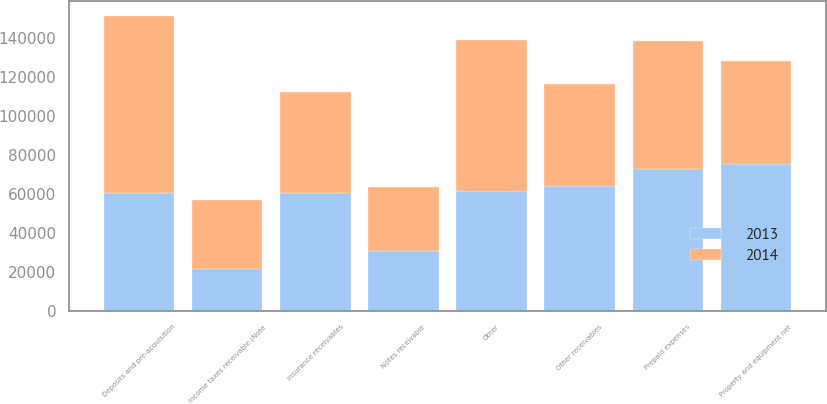Convert chart. <chart><loc_0><loc_0><loc_500><loc_500><stacked_bar_chart><ecel><fcel>Insurance receivables<fcel>Notes receivable<fcel>Other receivables<fcel>Prepaid expenses<fcel>Deposits and pre-acquisition<fcel>Property and equipment net<fcel>Income taxes receivable (Note<fcel>Other<nl><fcel>2013<fcel>60598<fcel>30699<fcel>63867<fcel>72585<fcel>60598<fcel>75219<fcel>21330<fcel>61454<nl><fcel>2014<fcel>51764<fcel>32944<fcel>52720<fcel>65965<fcel>91034<fcel>53051<fcel>35437<fcel>77706<nl></chart> 